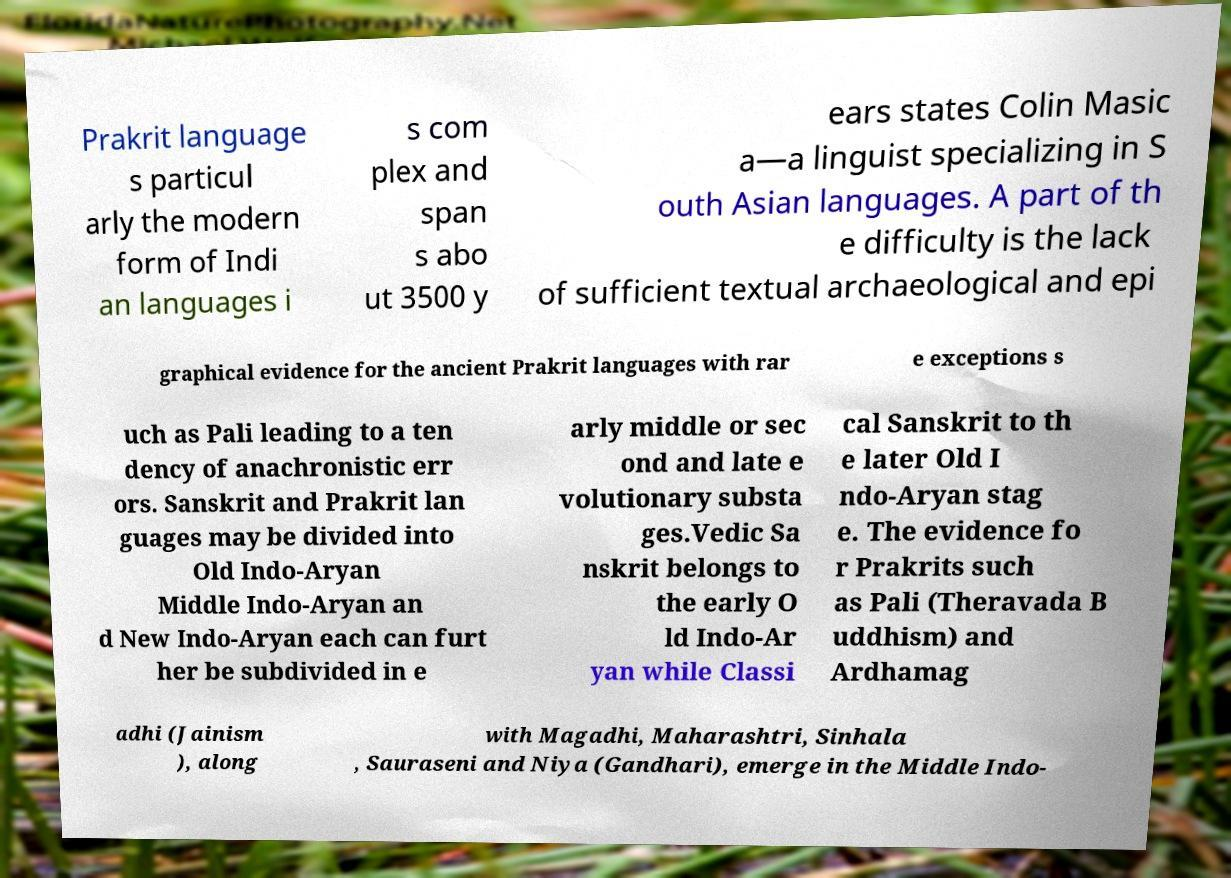What messages or text are displayed in this image? I need them in a readable, typed format. Prakrit language s particul arly the modern form of Indi an languages i s com plex and span s abo ut 3500 y ears states Colin Masic a—a linguist specializing in S outh Asian languages. A part of th e difficulty is the lack of sufficient textual archaeological and epi graphical evidence for the ancient Prakrit languages with rar e exceptions s uch as Pali leading to a ten dency of anachronistic err ors. Sanskrit and Prakrit lan guages may be divided into Old Indo-Aryan Middle Indo-Aryan an d New Indo-Aryan each can furt her be subdivided in e arly middle or sec ond and late e volutionary substa ges.Vedic Sa nskrit belongs to the early O ld Indo-Ar yan while Classi cal Sanskrit to th e later Old I ndo-Aryan stag e. The evidence fo r Prakrits such as Pali (Theravada B uddhism) and Ardhamag adhi (Jainism ), along with Magadhi, Maharashtri, Sinhala , Sauraseni and Niya (Gandhari), emerge in the Middle Indo- 